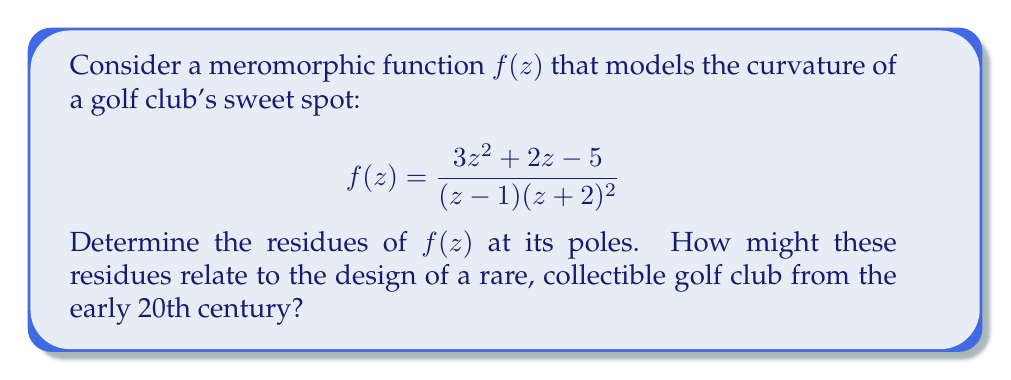What is the answer to this math problem? To find the residues of the meromorphic function $f(z)$, we need to identify its poles and calculate the residues at each pole.

1) First, let's identify the poles:
   The denominator of $f(z)$ is $(z-1)(z+2)^2$, so the poles are:
   - $z = 1$ (simple pole)
   - $z = -2$ (double pole)

2) For the simple pole at $z = 1$:
   We can use the formula for the residue at a simple pole:
   $$\text{Res}(f, 1) = \lim_{z \to 1} (z-1)f(z)$$
   $$= \lim_{z \to 1} \frac{3z^2 + 2z - 5}{(z+2)^2}$$
   $$= \frac{3(1)^2 + 2(1) - 5}{(1+2)^2} = \frac{0}{9} = 0$$

3) For the double pole at $z = -2$:
   We use the formula for the residue at a pole of order 2:
   $$\text{Res}(f, -2) = \lim_{z \to -2} \frac{d}{dz}[(z+2)^2f(z)]$$
   
   Let $g(z) = (z+2)^2f(z) = \frac{3z^2 + 2z - 5}{z-1}$
   
   $$\frac{d}{dz}g(z) = \frac{(6z+2)(z-1) - (3z^2 + 2z - 5)}{(z-1)^2}$$
   
   Evaluating at $z = -2$:
   $$\text{Res}(f, -2) = \frac{(-12+2)(-3) - (12 - 4 - 5)}{(-3)^2} = \frac{-30 - 3}{9} = -\frac{11}{3}$$

These residues provide information about the behavior of the function near its singularities, which in the context of a golf club's sweet spot, could relate to the sensitivity of the club face at certain points. For a rare, collectible golf club from the early 20th century, these mathematical properties might reflect innovative design features that were ahead of their time, potentially explaining why the club became a valuable collector's item.
Answer: The residues of $f(z)$ are:
$$\text{Res}(f, 1) = 0$$
$$\text{Res}(f, -2) = -\frac{11}{3}$$ 